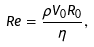Convert formula to latex. <formula><loc_0><loc_0><loc_500><loc_500>R e = \frac { \rho V _ { 0 } R _ { 0 } } { \eta } ,</formula> 